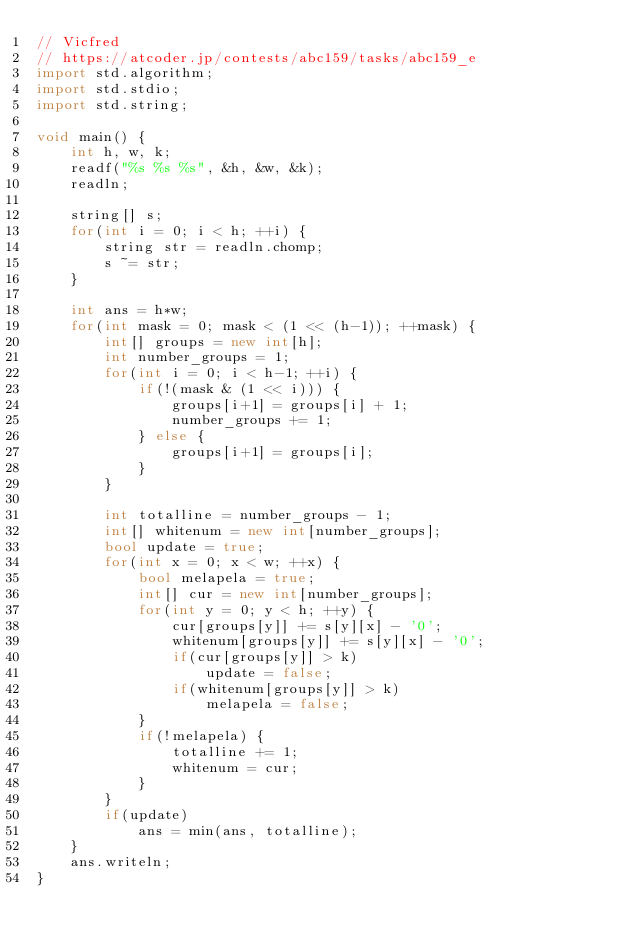Convert code to text. <code><loc_0><loc_0><loc_500><loc_500><_D_>// Vicfred
// https://atcoder.jp/contests/abc159/tasks/abc159_e
import std.algorithm;
import std.stdio;
import std.string;

void main() {
    int h, w, k;
    readf("%s %s %s", &h, &w, &k);
    readln;

    string[] s;
    for(int i = 0; i < h; ++i) {
        string str = readln.chomp;
        s ~= str;
    }

    int ans = h*w;
    for(int mask = 0; mask < (1 << (h-1)); ++mask) {
        int[] groups = new int[h];
        int number_groups = 1;
        for(int i = 0; i < h-1; ++i) {
            if(!(mask & (1 << i))) {
                groups[i+1] = groups[i] + 1;
                number_groups += 1;
            } else {
                groups[i+1] = groups[i];
            }
        }

        int totalline = number_groups - 1;
        int[] whitenum = new int[number_groups];
        bool update = true;
        for(int x = 0; x < w; ++x) {
            bool melapela = true;
            int[] cur = new int[number_groups];
            for(int y = 0; y < h; ++y) {
                cur[groups[y]] += s[y][x] - '0';
                whitenum[groups[y]] += s[y][x] - '0';
                if(cur[groups[y]] > k)
                    update = false;
                if(whitenum[groups[y]] > k)
                    melapela = false;
            }
            if(!melapela) {
                totalline += 1;
                whitenum = cur;
            }
        }
        if(update)
            ans = min(ans, totalline);
    }
    ans.writeln;
}

</code> 